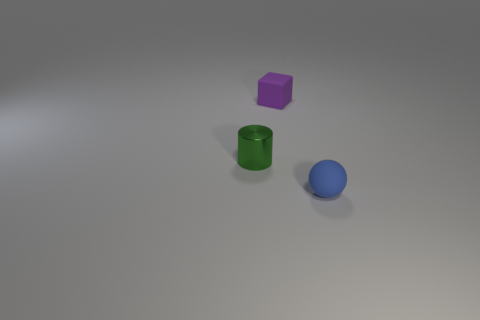There is a tiny object that is in front of the tiny green shiny object; is it the same color as the tiny matte thing left of the small blue matte sphere?
Provide a succinct answer. No. Is there any other thing that is the same material as the ball?
Provide a succinct answer. Yes. There is a blue rubber object; are there any tiny matte things in front of it?
Give a very brief answer. No. Is the number of cylinders to the left of the green object the same as the number of large green cylinders?
Offer a terse response. Yes. Is there a purple cube behind the small matte object that is in front of the rubber object to the left of the tiny blue ball?
Provide a short and direct response. Yes. What material is the small green thing?
Give a very brief answer. Metal. What number of other things are there of the same shape as the tiny blue object?
Provide a short and direct response. 0. Is the metallic thing the same shape as the purple rubber thing?
Ensure brevity in your answer.  No. What number of things are either matte objects that are behind the blue object or tiny objects that are to the right of the small cylinder?
Ensure brevity in your answer.  2. What number of objects are either small yellow cylinders or small blue rubber objects?
Keep it short and to the point. 1. 